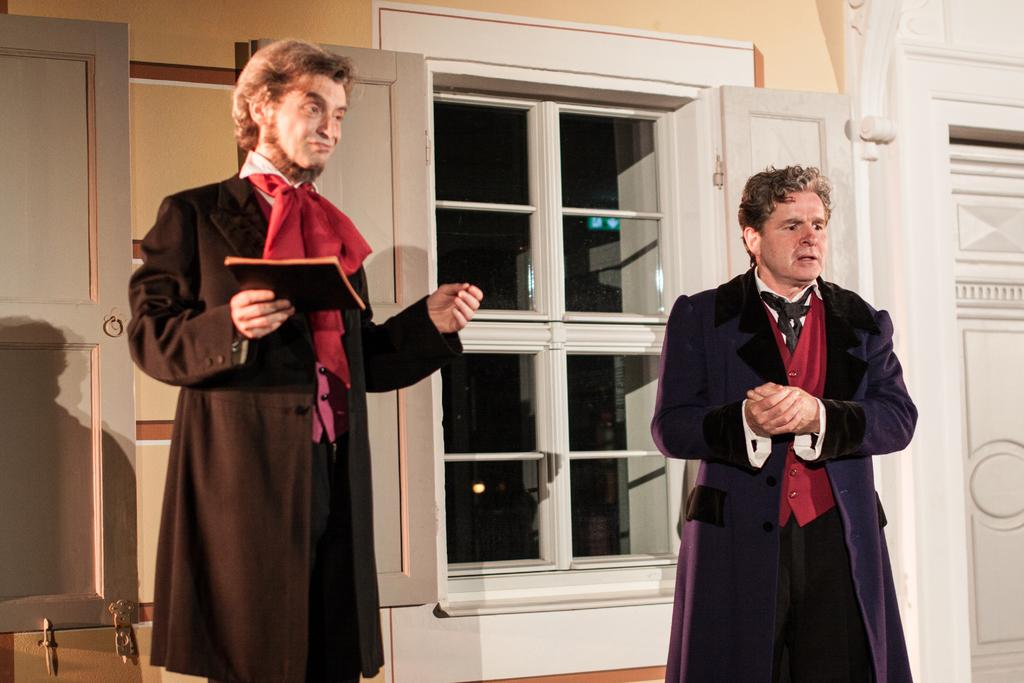How many people are in the image? There are two men standing in the image. What is one of the men holding? One man is holding a book in his hand. What can be seen in the background of the image? There are windows, a door, and a wall in the background of the image. Can you tell me what the ghost is saying to the men in the image? There is no ghost present in the image, so it is not possible to determine what the ghost might be saying. 